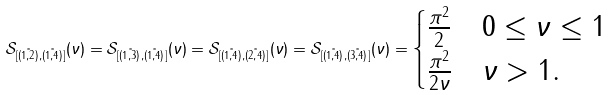Convert formula to latex. <formula><loc_0><loc_0><loc_500><loc_500>\mathcal { S } _ { [ \tilde { ( 1 , 2 ) } , \tilde { ( 1 , 4 ) } ] } ( \nu ) = \mathcal { S } _ { [ \tilde { ( 1 , 3 ) } , \tilde { ( 1 , 4 ) } ] } ( \nu ) = \mathcal { S } _ { [ \tilde { ( 1 , 4 ) } , \tilde { ( 2 , 4 ) } ] } ( \nu ) = \mathcal { S } _ { [ \tilde { ( 1 , 4 ) } , \tilde { ( 3 , 4 ) } ] } ( \nu ) = \begin{cases} \frac { \pi ^ { 2 } } { 2 } & 0 \leq \nu \leq 1 \\ \frac { \pi ^ { 2 } } { 2 \nu } & \nu > 1 . \end{cases}</formula> 